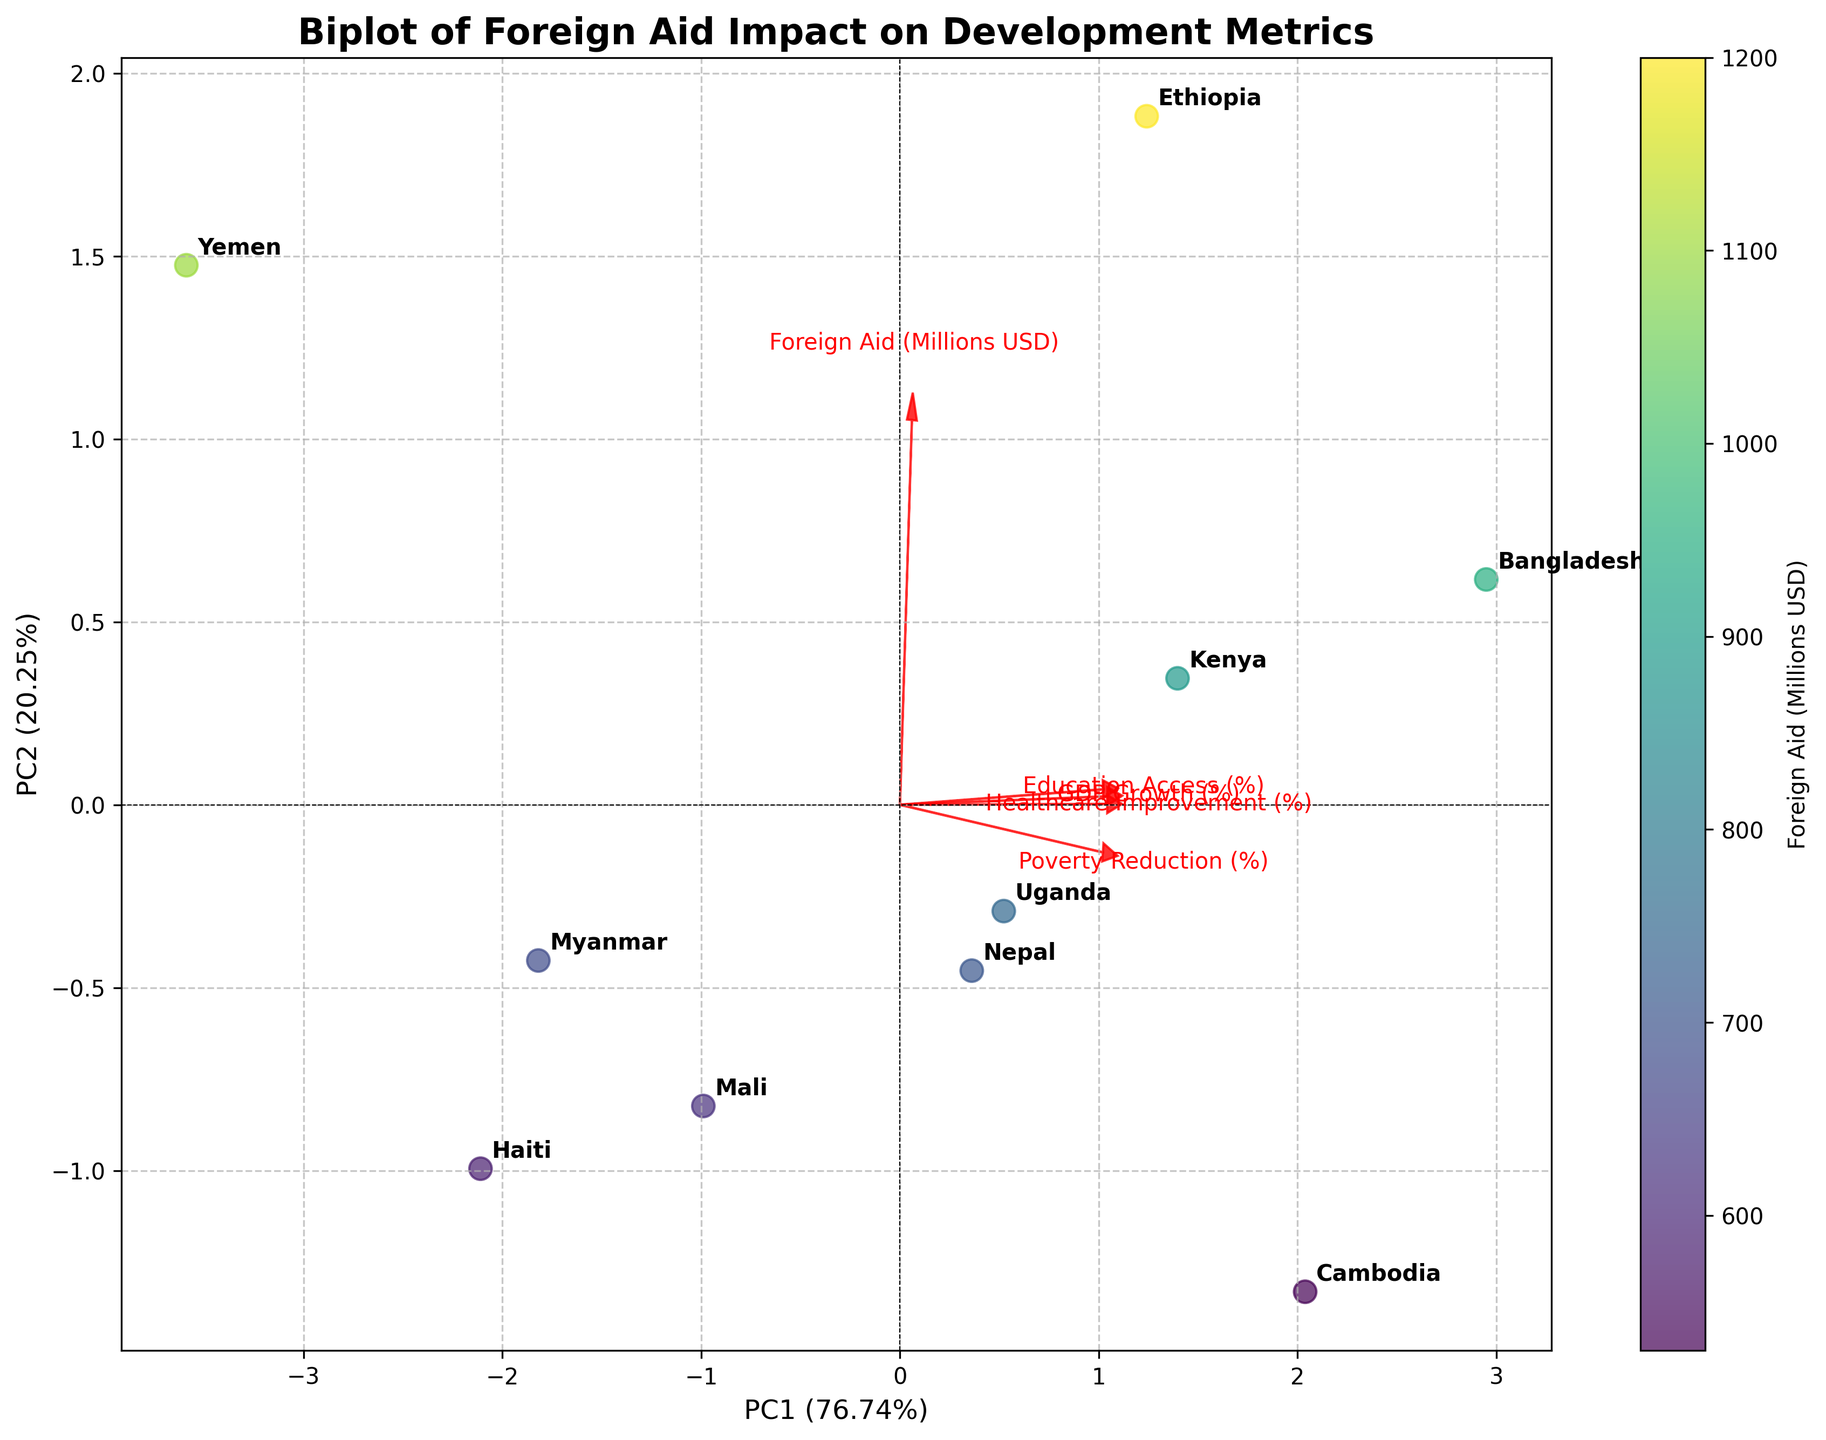What is the title of the biplot? The title of the plot is typically located at the top of the image, and it provides a brief description of the visual data. In this biplot, it reads "Biplot of Foreign Aid Impact on Development Metrics."
Answer: Biplot of Foreign Aid Impact on Development Metrics How is the x-axis labeled? The x-axis label is usually located at the bottom of the plot, indicating what the horizontal axis represents. In this case, the x-axis is labeled "PC1 (Percentage of variance explained by PC1)."
Answer: PC1 (Percentage of variance explained by PC1) Which country received the highest amount of foreign aid? The scatter plot points are color-coded by the amount of foreign aid received. The color bar on the right provides a reference. By finding the darkest data point, we can identify which country it corresponds to based on the annotations near the points.
Answer: Ethiopia How many countries are plotted in total? Each country is represented by a labeled data point in the scatter plot. By counting these labeled points, we can determine the total number of countries shown.
Answer: 10 What feature is represented by the vector pointing furthest to the right? The vectors represent different features, with their direction and length indicating the contribution to the principal components. The feature with the vector pointing furthest to the right (in the positive x-direction) can be identified by its label at the tip of the vector.
Answer: Foreign Aid (Millions USD) Which country shows the highest GDP growth (%)? To find which country has the highest GDP growth, look for the country nearest to the vector associated with "GDP Growth (%)". Based on the direction and length of the vector, find the labeled data point closest to it.
Answer: Bangladesh What are the two principal components labeled on the axes, and what percentage of the variance do they each explain? The labels for the principal components are located on the x-axis and y-axis, along with the percentages they explain in parentheses. PC1 and PC2 are marked with their respective explanations.
Answer: PC1: 43.5%, PC2: 26.6% How do 'Education Access (%)' and 'Healthcare Improvement (%)' compare in their contributions to the biplot? Comparing vectors requires observing their direction and magnitude. The vector directions and lengths for 'Education Access (%)' and 'Healthcare Improvement (%)' can be compared directly by the arrows representing these features.
Answer: Education Access (%) has a larger contribution than Healthcare Improvement (%) In which direction should you look to find countries with high poverty reduction? The vector for "Poverty Reduction (%)" indicates the direction in which this particular metric increases. Assess the direction of this vector and look for the countries situated closest to its endpoint.
Answer: Top-right quadrant Why is Bangladesh located where it is on the biplot? The position of Bangladesh is determined by its values for the different features standardized and transformed into the principal component space. By examining its proximity to the different vectors, conclusions can be drawn about its performance metrics.
Answer: High GDP growth, moderate foreign aid 